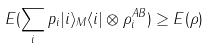<formula> <loc_0><loc_0><loc_500><loc_500>E ( \sum _ { i } p _ { i } | i \rangle _ { M } \langle i | \otimes \rho _ { i } ^ { A B } ) \geq E ( \rho )</formula> 